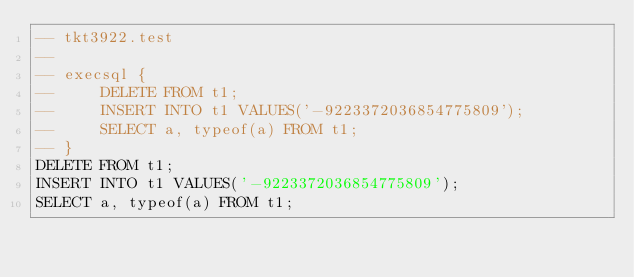<code> <loc_0><loc_0><loc_500><loc_500><_SQL_>-- tkt3922.test
-- 
-- execsql {
--     DELETE FROM t1;
--     INSERT INTO t1 VALUES('-9223372036854775809');
--     SELECT a, typeof(a) FROM t1;
-- }
DELETE FROM t1;
INSERT INTO t1 VALUES('-9223372036854775809');
SELECT a, typeof(a) FROM t1;</code> 